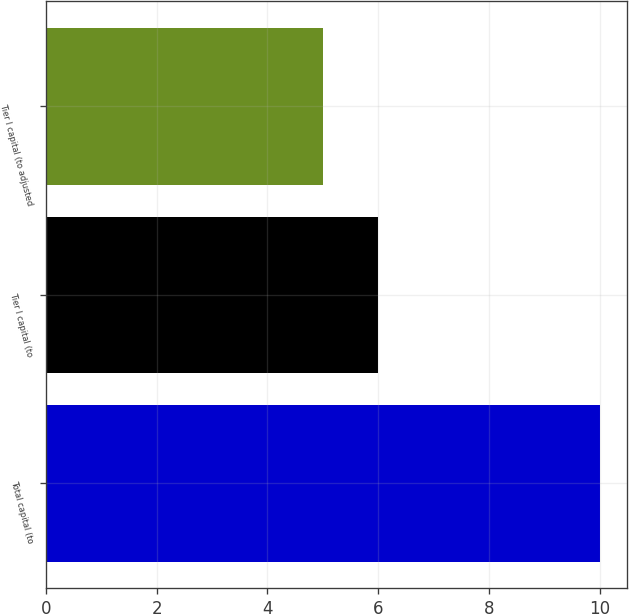Convert chart to OTSL. <chart><loc_0><loc_0><loc_500><loc_500><bar_chart><fcel>Total capital (to<fcel>Tier I capital (to<fcel>Tier I capital (to adjusted<nl><fcel>10<fcel>6<fcel>5<nl></chart> 